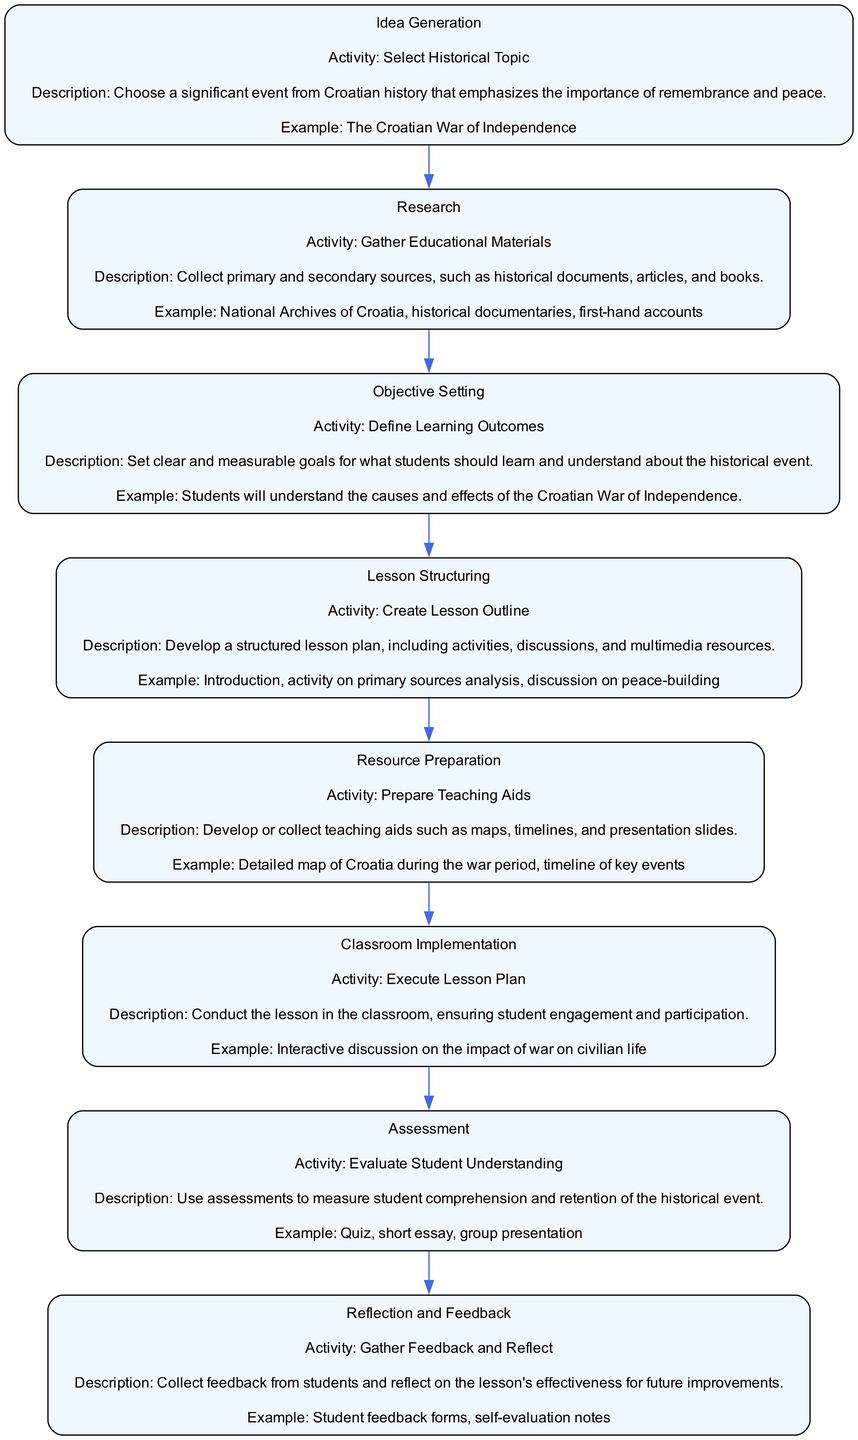What is the first activity mentioned in the workflow? The first step in the workflow is "Idea Generation," which includes the activity "Select Historical Topic." This can be directly found in the diagram's initial node.
Answer: Select Historical Topic What is the final step of the lesson planning workflow? The last activity in the workflow is "Reflection and Feedback," which concludes the planning process. The diagram shows arrows leading towards this last node.
Answer: Reflection and Feedback How many activities are listed in the lesson planning workflow? By counting each unique activity represented in the individual nodes of the diagram, we see there are eight activities in total.
Answer: Eight What is the description provided for "Classroom Implementation"? The node related to "Classroom Implementation" states its description as "Conduct the lesson in the classroom, ensuring student engagement and participation." This is explicitly stated within the node content.
Answer: Conduct the lesson in the classroom, ensuring student engagement and participation Which activity involves gathering educational materials? The activity that involves gathering educational materials is "Research," as indicated in the corresponding node of the diagram. It explicitly highlights this as part of the workflow.
Answer: Research What are the learning outcomes defined in "Objective Setting"? In the diagram under "Objective Setting," the learning outcome is articulated as: "Students will understand the causes and effects of the Croatian War of Independence." This is noted in the node's description.
Answer: Students will understand the causes and effects of the Croatian War of Independence How many nodes directly precede the "Assessment" node? The "Assessment" node has one node directly preceding it, which is "Classroom Implementation." The flow can be traced from one to the next in the diagram.
Answer: One What type of materials should be prepared in "Resource Preparation"? The "Resource Preparation" activity mentions the development or collection of teaching aids such as maps, timelines, and presentation slides. This detail is present within that specific node.
Answer: Teaching aids such as maps, timelines, and presentation slides 